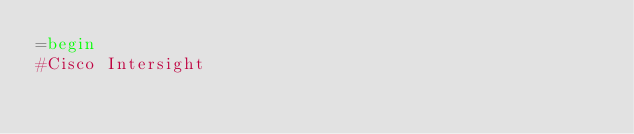Convert code to text. <code><loc_0><loc_0><loc_500><loc_500><_Ruby_>=begin
#Cisco Intersight
</code> 